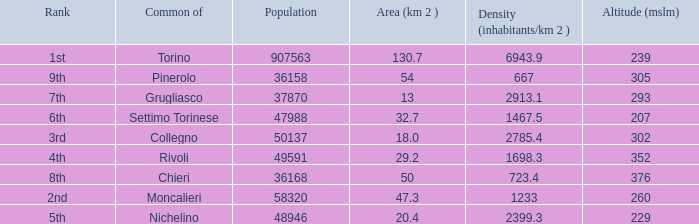What rank is the common with an area of 47.3 km^2? 2nd. 